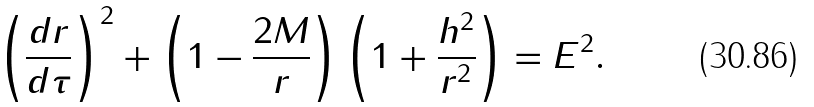<formula> <loc_0><loc_0><loc_500><loc_500>\left ( \frac { d r } { d \tau } \right ) ^ { 2 } + \left ( 1 - \frac { 2 M } { r } \right ) \left ( 1 + \frac { h ^ { 2 } } { r ^ { 2 } } \right ) = E ^ { 2 } .</formula> 